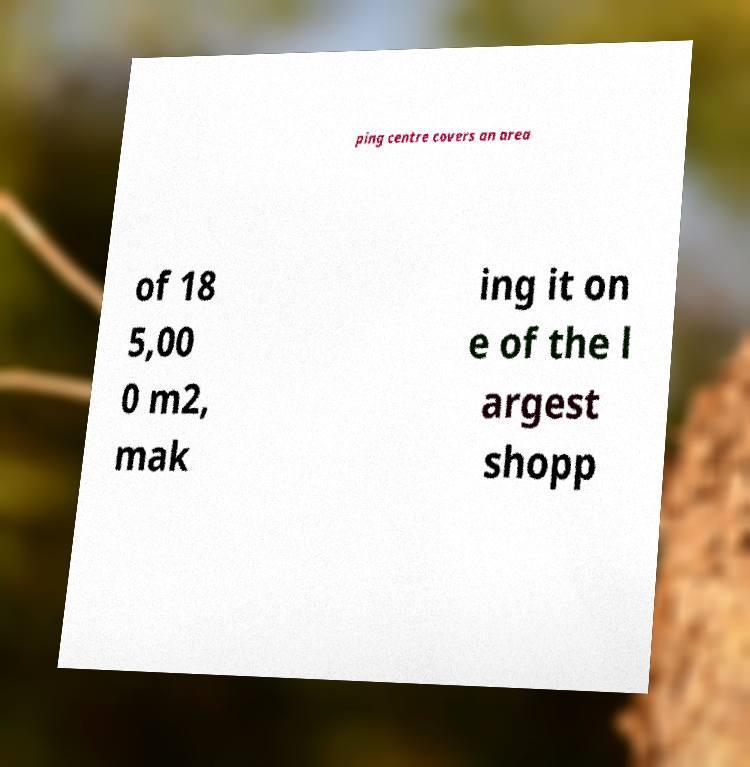I need the written content from this picture converted into text. Can you do that? ping centre covers an area of 18 5,00 0 m2, mak ing it on e of the l argest shopp 